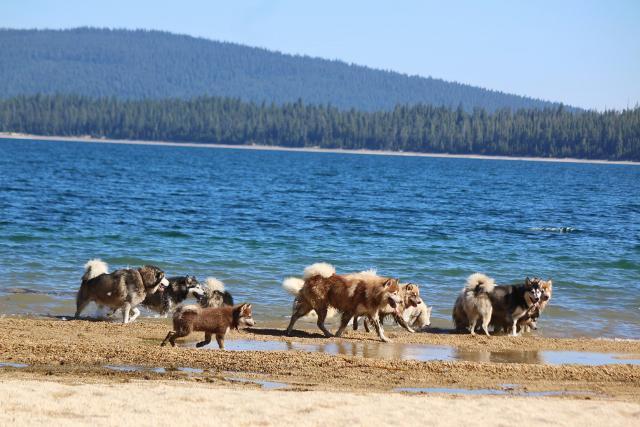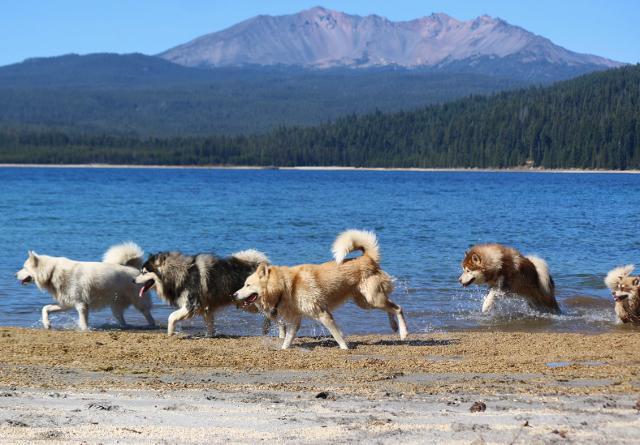The first image is the image on the left, the second image is the image on the right. For the images shown, is this caption "There is a single dog in the snow in one image." true? Answer yes or no. No. 